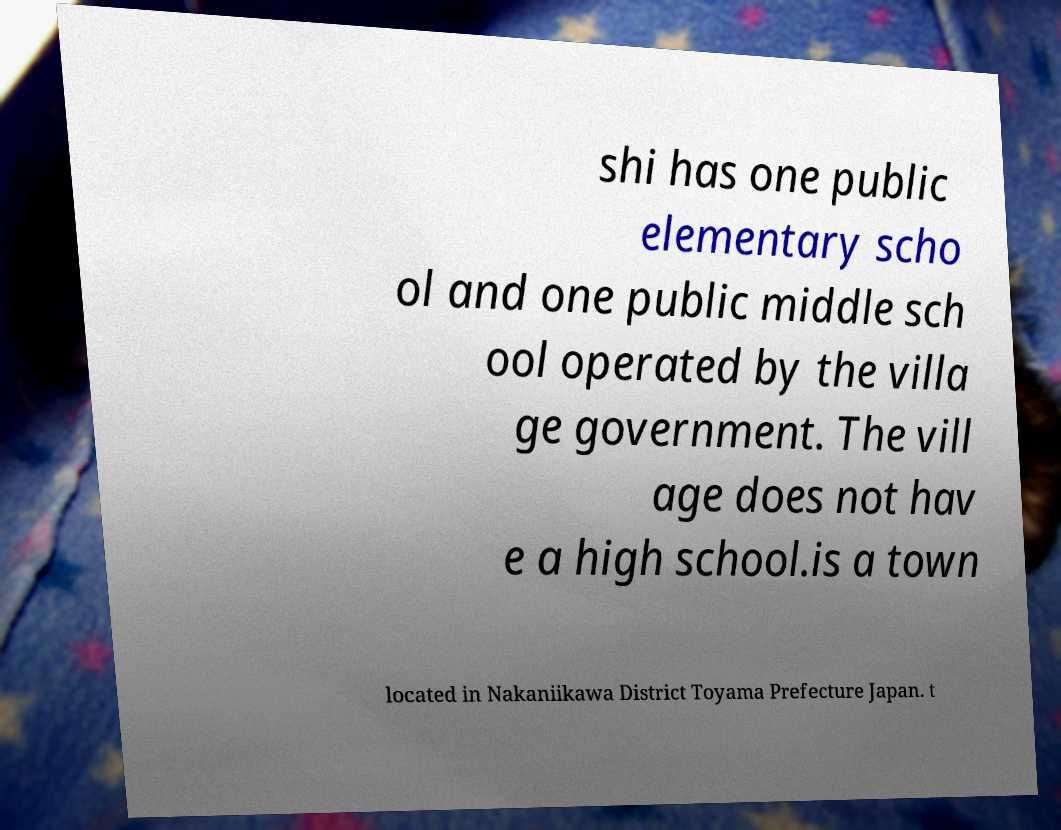For documentation purposes, I need the text within this image transcribed. Could you provide that? shi has one public elementary scho ol and one public middle sch ool operated by the villa ge government. The vill age does not hav e a high school.is a town located in Nakaniikawa District Toyama Prefecture Japan. t 